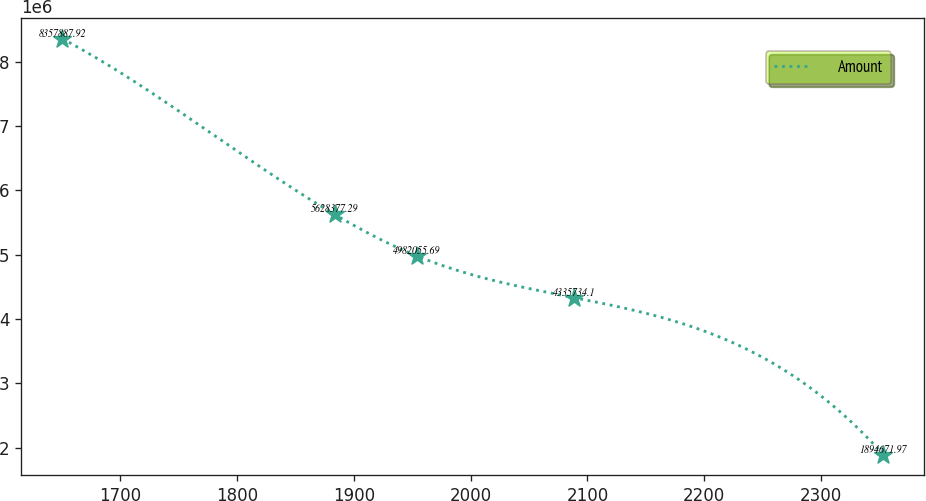Convert chart to OTSL. <chart><loc_0><loc_0><loc_500><loc_500><line_chart><ecel><fcel>Amount<nl><fcel>1650.21<fcel>8.35789e+06<nl><fcel>1883.49<fcel>5.62838e+06<nl><fcel>1953.81<fcel>4.98206e+06<nl><fcel>2088.14<fcel>4.33573e+06<nl><fcel>2353.42<fcel>1.89467e+06<nl></chart> 